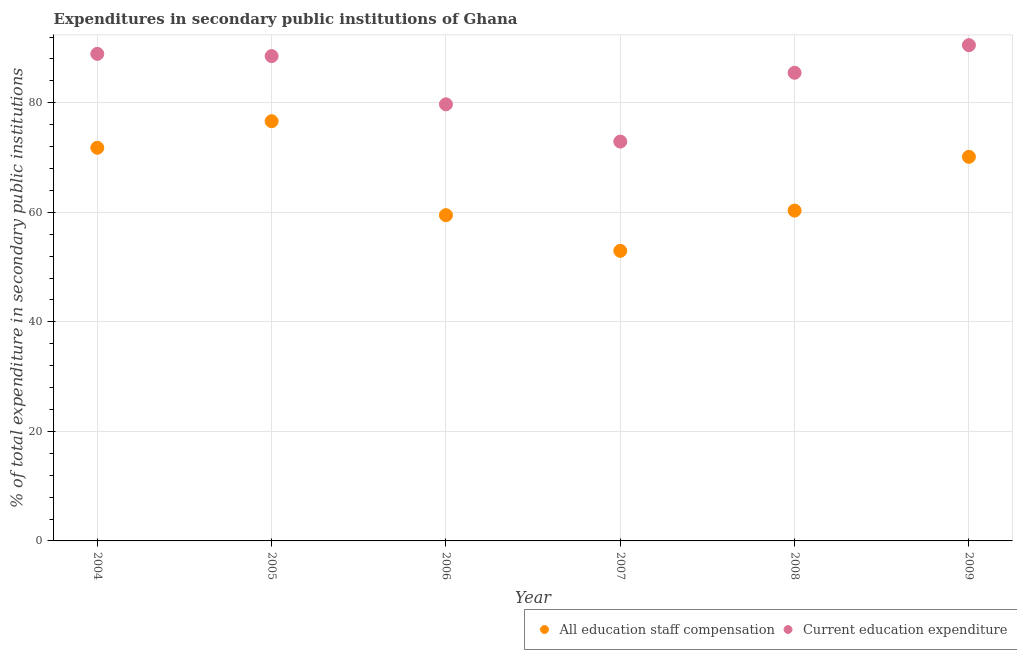How many different coloured dotlines are there?
Your response must be concise. 2. What is the expenditure in staff compensation in 2005?
Make the answer very short. 76.63. Across all years, what is the maximum expenditure in education?
Offer a very short reply. 90.52. Across all years, what is the minimum expenditure in staff compensation?
Your answer should be very brief. 52.97. In which year was the expenditure in education maximum?
Keep it short and to the point. 2009. What is the total expenditure in education in the graph?
Make the answer very short. 506.07. What is the difference between the expenditure in education in 2006 and that in 2009?
Your answer should be very brief. -10.8. What is the difference between the expenditure in staff compensation in 2007 and the expenditure in education in 2005?
Your answer should be very brief. -35.56. What is the average expenditure in education per year?
Your answer should be very brief. 84.35. In the year 2009, what is the difference between the expenditure in education and expenditure in staff compensation?
Make the answer very short. 20.39. In how many years, is the expenditure in staff compensation greater than 20 %?
Your answer should be very brief. 6. What is the ratio of the expenditure in staff compensation in 2005 to that in 2008?
Offer a very short reply. 1.27. Is the expenditure in education in 2004 less than that in 2008?
Offer a very short reply. No. Is the difference between the expenditure in education in 2004 and 2009 greater than the difference between the expenditure in staff compensation in 2004 and 2009?
Provide a succinct answer. No. What is the difference between the highest and the second highest expenditure in staff compensation?
Give a very brief answer. 4.85. What is the difference between the highest and the lowest expenditure in education?
Provide a succinct answer. 17.61. In how many years, is the expenditure in staff compensation greater than the average expenditure in staff compensation taken over all years?
Keep it short and to the point. 3. Is the sum of the expenditure in staff compensation in 2004 and 2007 greater than the maximum expenditure in education across all years?
Offer a terse response. Yes. Does the expenditure in staff compensation monotonically increase over the years?
Ensure brevity in your answer.  No. Is the expenditure in staff compensation strictly greater than the expenditure in education over the years?
Your answer should be compact. No. Is the expenditure in staff compensation strictly less than the expenditure in education over the years?
Offer a terse response. Yes. Are the values on the major ticks of Y-axis written in scientific E-notation?
Your answer should be very brief. No. Does the graph contain any zero values?
Provide a short and direct response. No. Does the graph contain grids?
Provide a short and direct response. Yes. Where does the legend appear in the graph?
Your answer should be compact. Bottom right. How many legend labels are there?
Offer a very short reply. 2. How are the legend labels stacked?
Your answer should be very brief. Horizontal. What is the title of the graph?
Provide a short and direct response. Expenditures in secondary public institutions of Ghana. What is the label or title of the Y-axis?
Keep it short and to the point. % of total expenditure in secondary public institutions. What is the % of total expenditure in secondary public institutions in All education staff compensation in 2004?
Make the answer very short. 71.79. What is the % of total expenditure in secondary public institutions of Current education expenditure in 2004?
Provide a short and direct response. 88.93. What is the % of total expenditure in secondary public institutions of All education staff compensation in 2005?
Provide a short and direct response. 76.63. What is the % of total expenditure in secondary public institutions of Current education expenditure in 2005?
Make the answer very short. 88.52. What is the % of total expenditure in secondary public institutions of All education staff compensation in 2006?
Provide a succinct answer. 59.48. What is the % of total expenditure in secondary public institutions in Current education expenditure in 2006?
Offer a terse response. 79.72. What is the % of total expenditure in secondary public institutions in All education staff compensation in 2007?
Provide a short and direct response. 52.97. What is the % of total expenditure in secondary public institutions of Current education expenditure in 2007?
Your answer should be compact. 72.91. What is the % of total expenditure in secondary public institutions of All education staff compensation in 2008?
Offer a terse response. 60.31. What is the % of total expenditure in secondary public institutions in Current education expenditure in 2008?
Offer a terse response. 85.48. What is the % of total expenditure in secondary public institutions in All education staff compensation in 2009?
Your answer should be very brief. 70.13. What is the % of total expenditure in secondary public institutions of Current education expenditure in 2009?
Provide a short and direct response. 90.52. Across all years, what is the maximum % of total expenditure in secondary public institutions in All education staff compensation?
Your answer should be compact. 76.63. Across all years, what is the maximum % of total expenditure in secondary public institutions in Current education expenditure?
Your answer should be compact. 90.52. Across all years, what is the minimum % of total expenditure in secondary public institutions of All education staff compensation?
Provide a succinct answer. 52.97. Across all years, what is the minimum % of total expenditure in secondary public institutions in Current education expenditure?
Make the answer very short. 72.91. What is the total % of total expenditure in secondary public institutions of All education staff compensation in the graph?
Offer a very short reply. 391.31. What is the total % of total expenditure in secondary public institutions in Current education expenditure in the graph?
Ensure brevity in your answer.  506.07. What is the difference between the % of total expenditure in secondary public institutions of All education staff compensation in 2004 and that in 2005?
Make the answer very short. -4.85. What is the difference between the % of total expenditure in secondary public institutions in Current education expenditure in 2004 and that in 2005?
Keep it short and to the point. 0.4. What is the difference between the % of total expenditure in secondary public institutions in All education staff compensation in 2004 and that in 2006?
Make the answer very short. 12.31. What is the difference between the % of total expenditure in secondary public institutions of Current education expenditure in 2004 and that in 2006?
Ensure brevity in your answer.  9.21. What is the difference between the % of total expenditure in secondary public institutions in All education staff compensation in 2004 and that in 2007?
Keep it short and to the point. 18.82. What is the difference between the % of total expenditure in secondary public institutions of Current education expenditure in 2004 and that in 2007?
Offer a very short reply. 16.02. What is the difference between the % of total expenditure in secondary public institutions of All education staff compensation in 2004 and that in 2008?
Give a very brief answer. 11.47. What is the difference between the % of total expenditure in secondary public institutions of Current education expenditure in 2004 and that in 2008?
Provide a succinct answer. 3.45. What is the difference between the % of total expenditure in secondary public institutions in All education staff compensation in 2004 and that in 2009?
Provide a succinct answer. 1.65. What is the difference between the % of total expenditure in secondary public institutions in Current education expenditure in 2004 and that in 2009?
Give a very brief answer. -1.59. What is the difference between the % of total expenditure in secondary public institutions in All education staff compensation in 2005 and that in 2006?
Provide a short and direct response. 17.16. What is the difference between the % of total expenditure in secondary public institutions of Current education expenditure in 2005 and that in 2006?
Offer a terse response. 8.81. What is the difference between the % of total expenditure in secondary public institutions in All education staff compensation in 2005 and that in 2007?
Offer a very short reply. 23.67. What is the difference between the % of total expenditure in secondary public institutions in Current education expenditure in 2005 and that in 2007?
Keep it short and to the point. 15.61. What is the difference between the % of total expenditure in secondary public institutions of All education staff compensation in 2005 and that in 2008?
Your answer should be very brief. 16.32. What is the difference between the % of total expenditure in secondary public institutions of Current education expenditure in 2005 and that in 2008?
Provide a short and direct response. 3.05. What is the difference between the % of total expenditure in secondary public institutions in All education staff compensation in 2005 and that in 2009?
Make the answer very short. 6.5. What is the difference between the % of total expenditure in secondary public institutions in Current education expenditure in 2005 and that in 2009?
Give a very brief answer. -2. What is the difference between the % of total expenditure in secondary public institutions in All education staff compensation in 2006 and that in 2007?
Give a very brief answer. 6.51. What is the difference between the % of total expenditure in secondary public institutions in Current education expenditure in 2006 and that in 2007?
Ensure brevity in your answer.  6.81. What is the difference between the % of total expenditure in secondary public institutions in All education staff compensation in 2006 and that in 2008?
Your response must be concise. -0.84. What is the difference between the % of total expenditure in secondary public institutions in Current education expenditure in 2006 and that in 2008?
Provide a succinct answer. -5.76. What is the difference between the % of total expenditure in secondary public institutions in All education staff compensation in 2006 and that in 2009?
Your answer should be compact. -10.65. What is the difference between the % of total expenditure in secondary public institutions in Current education expenditure in 2006 and that in 2009?
Your answer should be very brief. -10.8. What is the difference between the % of total expenditure in secondary public institutions of All education staff compensation in 2007 and that in 2008?
Your answer should be compact. -7.35. What is the difference between the % of total expenditure in secondary public institutions of Current education expenditure in 2007 and that in 2008?
Keep it short and to the point. -12.57. What is the difference between the % of total expenditure in secondary public institutions of All education staff compensation in 2007 and that in 2009?
Give a very brief answer. -17.17. What is the difference between the % of total expenditure in secondary public institutions of Current education expenditure in 2007 and that in 2009?
Your answer should be very brief. -17.61. What is the difference between the % of total expenditure in secondary public institutions of All education staff compensation in 2008 and that in 2009?
Provide a short and direct response. -9.82. What is the difference between the % of total expenditure in secondary public institutions of Current education expenditure in 2008 and that in 2009?
Offer a very short reply. -5.04. What is the difference between the % of total expenditure in secondary public institutions in All education staff compensation in 2004 and the % of total expenditure in secondary public institutions in Current education expenditure in 2005?
Keep it short and to the point. -16.74. What is the difference between the % of total expenditure in secondary public institutions in All education staff compensation in 2004 and the % of total expenditure in secondary public institutions in Current education expenditure in 2006?
Provide a short and direct response. -7.93. What is the difference between the % of total expenditure in secondary public institutions in All education staff compensation in 2004 and the % of total expenditure in secondary public institutions in Current education expenditure in 2007?
Provide a succinct answer. -1.12. What is the difference between the % of total expenditure in secondary public institutions of All education staff compensation in 2004 and the % of total expenditure in secondary public institutions of Current education expenditure in 2008?
Provide a succinct answer. -13.69. What is the difference between the % of total expenditure in secondary public institutions in All education staff compensation in 2004 and the % of total expenditure in secondary public institutions in Current education expenditure in 2009?
Offer a very short reply. -18.73. What is the difference between the % of total expenditure in secondary public institutions of All education staff compensation in 2005 and the % of total expenditure in secondary public institutions of Current education expenditure in 2006?
Give a very brief answer. -3.08. What is the difference between the % of total expenditure in secondary public institutions of All education staff compensation in 2005 and the % of total expenditure in secondary public institutions of Current education expenditure in 2007?
Your answer should be very brief. 3.72. What is the difference between the % of total expenditure in secondary public institutions in All education staff compensation in 2005 and the % of total expenditure in secondary public institutions in Current education expenditure in 2008?
Offer a very short reply. -8.84. What is the difference between the % of total expenditure in secondary public institutions in All education staff compensation in 2005 and the % of total expenditure in secondary public institutions in Current education expenditure in 2009?
Provide a short and direct response. -13.89. What is the difference between the % of total expenditure in secondary public institutions of All education staff compensation in 2006 and the % of total expenditure in secondary public institutions of Current education expenditure in 2007?
Provide a short and direct response. -13.43. What is the difference between the % of total expenditure in secondary public institutions of All education staff compensation in 2006 and the % of total expenditure in secondary public institutions of Current education expenditure in 2008?
Your response must be concise. -26. What is the difference between the % of total expenditure in secondary public institutions in All education staff compensation in 2006 and the % of total expenditure in secondary public institutions in Current education expenditure in 2009?
Keep it short and to the point. -31.04. What is the difference between the % of total expenditure in secondary public institutions of All education staff compensation in 2007 and the % of total expenditure in secondary public institutions of Current education expenditure in 2008?
Provide a succinct answer. -32.51. What is the difference between the % of total expenditure in secondary public institutions of All education staff compensation in 2007 and the % of total expenditure in secondary public institutions of Current education expenditure in 2009?
Your answer should be very brief. -37.55. What is the difference between the % of total expenditure in secondary public institutions of All education staff compensation in 2008 and the % of total expenditure in secondary public institutions of Current education expenditure in 2009?
Offer a very short reply. -30.21. What is the average % of total expenditure in secondary public institutions of All education staff compensation per year?
Your answer should be very brief. 65.22. What is the average % of total expenditure in secondary public institutions in Current education expenditure per year?
Make the answer very short. 84.35. In the year 2004, what is the difference between the % of total expenditure in secondary public institutions in All education staff compensation and % of total expenditure in secondary public institutions in Current education expenditure?
Make the answer very short. -17.14. In the year 2005, what is the difference between the % of total expenditure in secondary public institutions of All education staff compensation and % of total expenditure in secondary public institutions of Current education expenditure?
Your response must be concise. -11.89. In the year 2006, what is the difference between the % of total expenditure in secondary public institutions of All education staff compensation and % of total expenditure in secondary public institutions of Current education expenditure?
Ensure brevity in your answer.  -20.24. In the year 2007, what is the difference between the % of total expenditure in secondary public institutions in All education staff compensation and % of total expenditure in secondary public institutions in Current education expenditure?
Your answer should be compact. -19.94. In the year 2008, what is the difference between the % of total expenditure in secondary public institutions in All education staff compensation and % of total expenditure in secondary public institutions in Current education expenditure?
Provide a short and direct response. -25.16. In the year 2009, what is the difference between the % of total expenditure in secondary public institutions in All education staff compensation and % of total expenditure in secondary public institutions in Current education expenditure?
Your response must be concise. -20.39. What is the ratio of the % of total expenditure in secondary public institutions of All education staff compensation in 2004 to that in 2005?
Offer a very short reply. 0.94. What is the ratio of the % of total expenditure in secondary public institutions of All education staff compensation in 2004 to that in 2006?
Give a very brief answer. 1.21. What is the ratio of the % of total expenditure in secondary public institutions in Current education expenditure in 2004 to that in 2006?
Make the answer very short. 1.12. What is the ratio of the % of total expenditure in secondary public institutions of All education staff compensation in 2004 to that in 2007?
Ensure brevity in your answer.  1.36. What is the ratio of the % of total expenditure in secondary public institutions of Current education expenditure in 2004 to that in 2007?
Give a very brief answer. 1.22. What is the ratio of the % of total expenditure in secondary public institutions in All education staff compensation in 2004 to that in 2008?
Your response must be concise. 1.19. What is the ratio of the % of total expenditure in secondary public institutions of Current education expenditure in 2004 to that in 2008?
Make the answer very short. 1.04. What is the ratio of the % of total expenditure in secondary public institutions of All education staff compensation in 2004 to that in 2009?
Offer a terse response. 1.02. What is the ratio of the % of total expenditure in secondary public institutions of Current education expenditure in 2004 to that in 2009?
Offer a terse response. 0.98. What is the ratio of the % of total expenditure in secondary public institutions in All education staff compensation in 2005 to that in 2006?
Make the answer very short. 1.29. What is the ratio of the % of total expenditure in secondary public institutions in Current education expenditure in 2005 to that in 2006?
Your answer should be very brief. 1.11. What is the ratio of the % of total expenditure in secondary public institutions in All education staff compensation in 2005 to that in 2007?
Make the answer very short. 1.45. What is the ratio of the % of total expenditure in secondary public institutions of Current education expenditure in 2005 to that in 2007?
Offer a terse response. 1.21. What is the ratio of the % of total expenditure in secondary public institutions in All education staff compensation in 2005 to that in 2008?
Offer a terse response. 1.27. What is the ratio of the % of total expenditure in secondary public institutions of Current education expenditure in 2005 to that in 2008?
Provide a short and direct response. 1.04. What is the ratio of the % of total expenditure in secondary public institutions of All education staff compensation in 2005 to that in 2009?
Offer a very short reply. 1.09. What is the ratio of the % of total expenditure in secondary public institutions in Current education expenditure in 2005 to that in 2009?
Offer a very short reply. 0.98. What is the ratio of the % of total expenditure in secondary public institutions of All education staff compensation in 2006 to that in 2007?
Your answer should be very brief. 1.12. What is the ratio of the % of total expenditure in secondary public institutions of Current education expenditure in 2006 to that in 2007?
Offer a very short reply. 1.09. What is the ratio of the % of total expenditure in secondary public institutions in All education staff compensation in 2006 to that in 2008?
Make the answer very short. 0.99. What is the ratio of the % of total expenditure in secondary public institutions of Current education expenditure in 2006 to that in 2008?
Keep it short and to the point. 0.93. What is the ratio of the % of total expenditure in secondary public institutions of All education staff compensation in 2006 to that in 2009?
Ensure brevity in your answer.  0.85. What is the ratio of the % of total expenditure in secondary public institutions in Current education expenditure in 2006 to that in 2009?
Your answer should be very brief. 0.88. What is the ratio of the % of total expenditure in secondary public institutions in All education staff compensation in 2007 to that in 2008?
Provide a short and direct response. 0.88. What is the ratio of the % of total expenditure in secondary public institutions in Current education expenditure in 2007 to that in 2008?
Your answer should be compact. 0.85. What is the ratio of the % of total expenditure in secondary public institutions in All education staff compensation in 2007 to that in 2009?
Provide a succinct answer. 0.76. What is the ratio of the % of total expenditure in secondary public institutions in Current education expenditure in 2007 to that in 2009?
Offer a very short reply. 0.81. What is the ratio of the % of total expenditure in secondary public institutions of All education staff compensation in 2008 to that in 2009?
Ensure brevity in your answer.  0.86. What is the ratio of the % of total expenditure in secondary public institutions of Current education expenditure in 2008 to that in 2009?
Your answer should be compact. 0.94. What is the difference between the highest and the second highest % of total expenditure in secondary public institutions in All education staff compensation?
Keep it short and to the point. 4.85. What is the difference between the highest and the second highest % of total expenditure in secondary public institutions of Current education expenditure?
Your answer should be very brief. 1.59. What is the difference between the highest and the lowest % of total expenditure in secondary public institutions in All education staff compensation?
Offer a terse response. 23.67. What is the difference between the highest and the lowest % of total expenditure in secondary public institutions of Current education expenditure?
Keep it short and to the point. 17.61. 